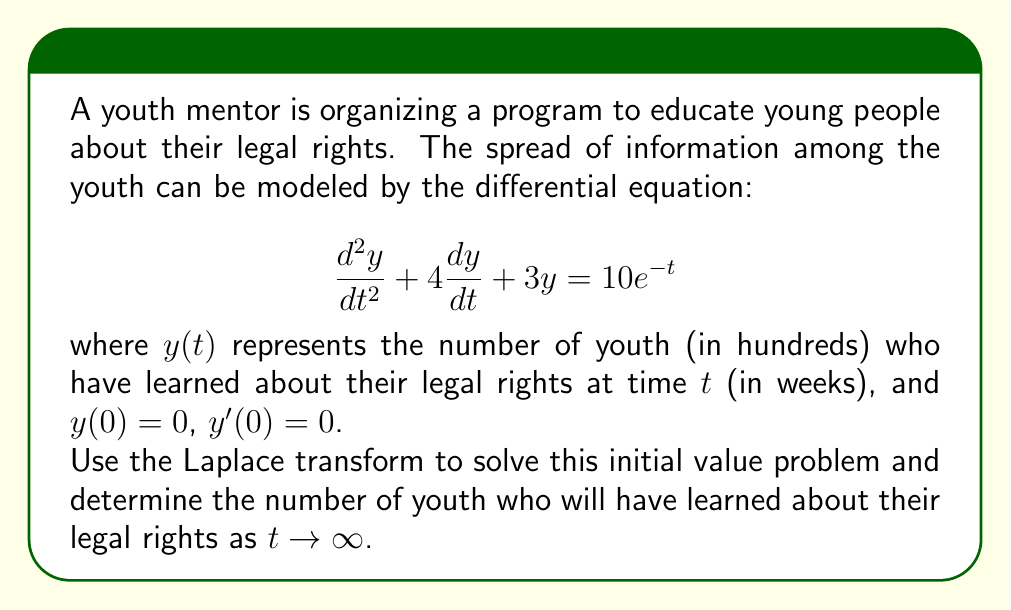Could you help me with this problem? Let's solve this step-by-step using the Laplace transform:

1) Take the Laplace transform of both sides of the equation:
   $$\mathcal{L}\{y''(t) + 4y'(t) + 3y(t)\} = \mathcal{L}\{10e^{-t}\}$$

2) Using the properties of the Laplace transform:
   $$(s^2Y(s) - sy(0) - y'(0)) + 4(sY(s) - y(0)) + 3Y(s) = \frac{10}{s+1}$$

3) Substitute the initial conditions $y(0) = 0$ and $y'(0) = 0$:
   $$s^2Y(s) + 4sY(s) + 3Y(s) = \frac{10}{s+1}$$

4) Factor out $Y(s)$:
   $$Y(s)(s^2 + 4s + 3) = \frac{10}{s+1}$$

5) Solve for $Y(s)$:
   $$Y(s) = \frac{10}{(s+1)(s^2 + 4s + 3)}$$

6) Factor the denominator:
   $$Y(s) = \frac{10}{(s+1)(s+1)(s+3)}$$

7) Use partial fraction decomposition:
   $$Y(s) = \frac{A}{s+1} + \frac{B}{(s+1)^2} + \frac{C}{s+3}$$

8) Solve for A, B, and C:
   $$A = 5/2, B = -5/2, C = 5/2$$

9) Rewrite $Y(s)$:
   $$Y(s) = \frac{5/2}{s+1} - \frac{5/2}{(s+1)^2} + \frac{5/2}{s+3}$$

10) Take the inverse Laplace transform:
    $$y(t) = \frac{5}{2}e^{-t} - \frac{5}{2}te^{-t} + \frac{5}{2}e^{-3t}$$

11) To find the limit as $t \to \infty$, note that all exponential terms approach 0:
    $$\lim_{t \to \infty} y(t) = 0$$

Therefore, as $t \to \infty$, the number of youth who have learned about their legal rights approaches 0 hundreds, or 0.
Answer: 0 